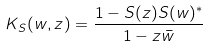<formula> <loc_0><loc_0><loc_500><loc_500>K _ { S } ( w , z ) = \frac { 1 - S ( z ) S ( w ) ^ { * } } { 1 - z \bar { w } }</formula> 